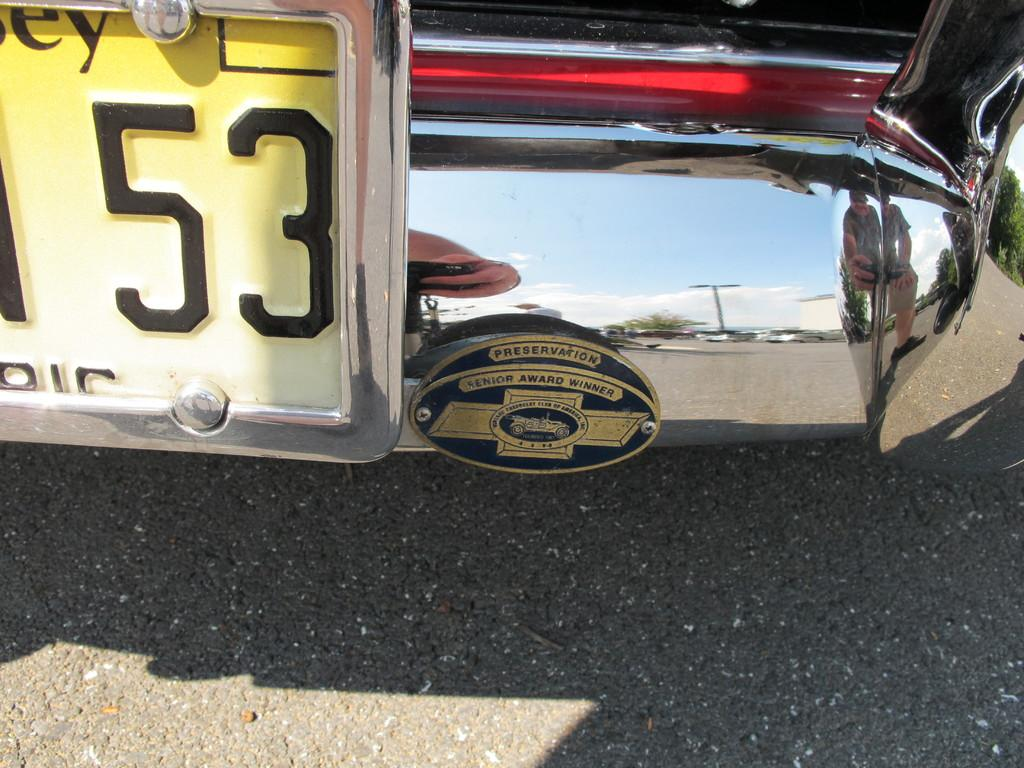What can be found in the left corner of the image? There is a number plate of a vehicle in the left corner of the image. What else is present in the image besides the number plate? There are other objects beside the number plate in the image. What type of nut is being cracked by the person in the image? There is no person or nut present in the image; it only features a number plate and other objects. 